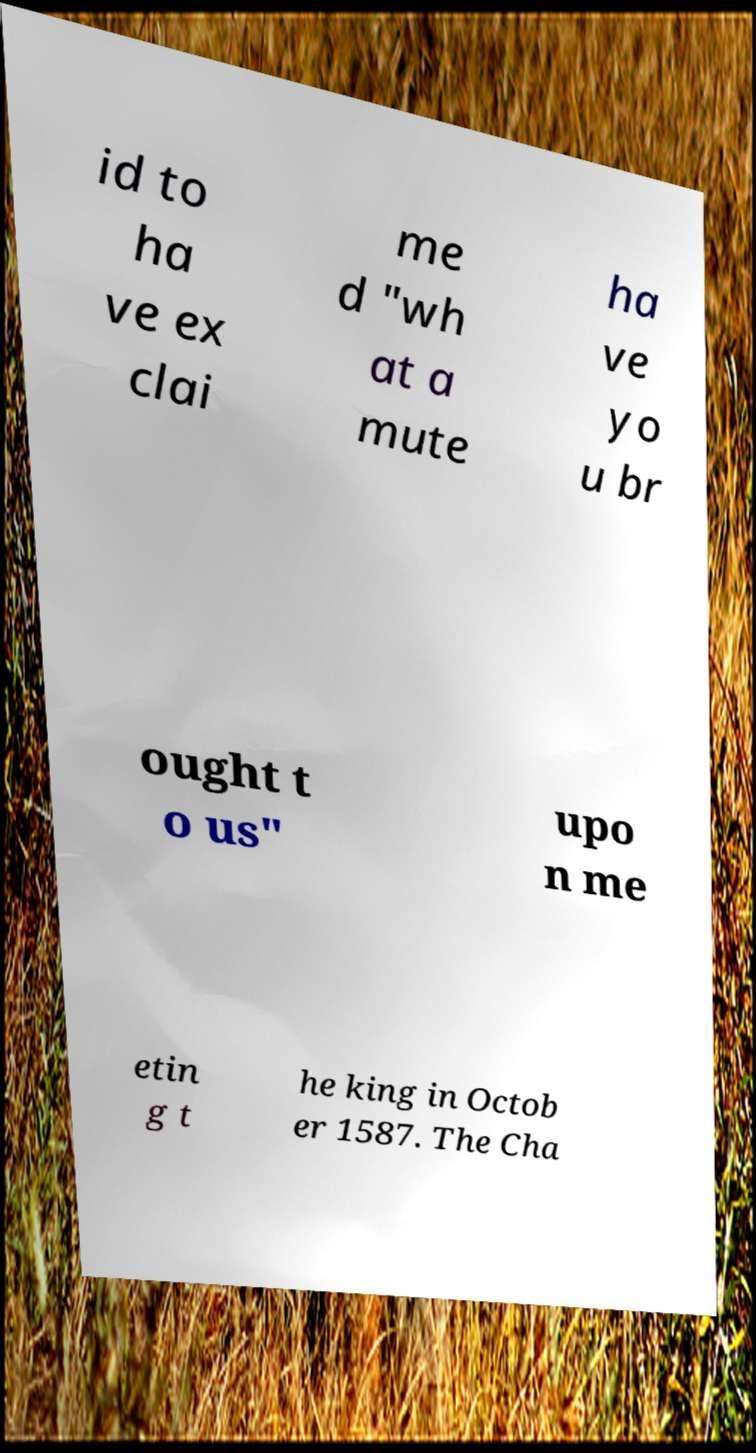There's text embedded in this image that I need extracted. Can you transcribe it verbatim? id to ha ve ex clai me d "wh at a mute ha ve yo u br ought t o us" upo n me etin g t he king in Octob er 1587. The Cha 